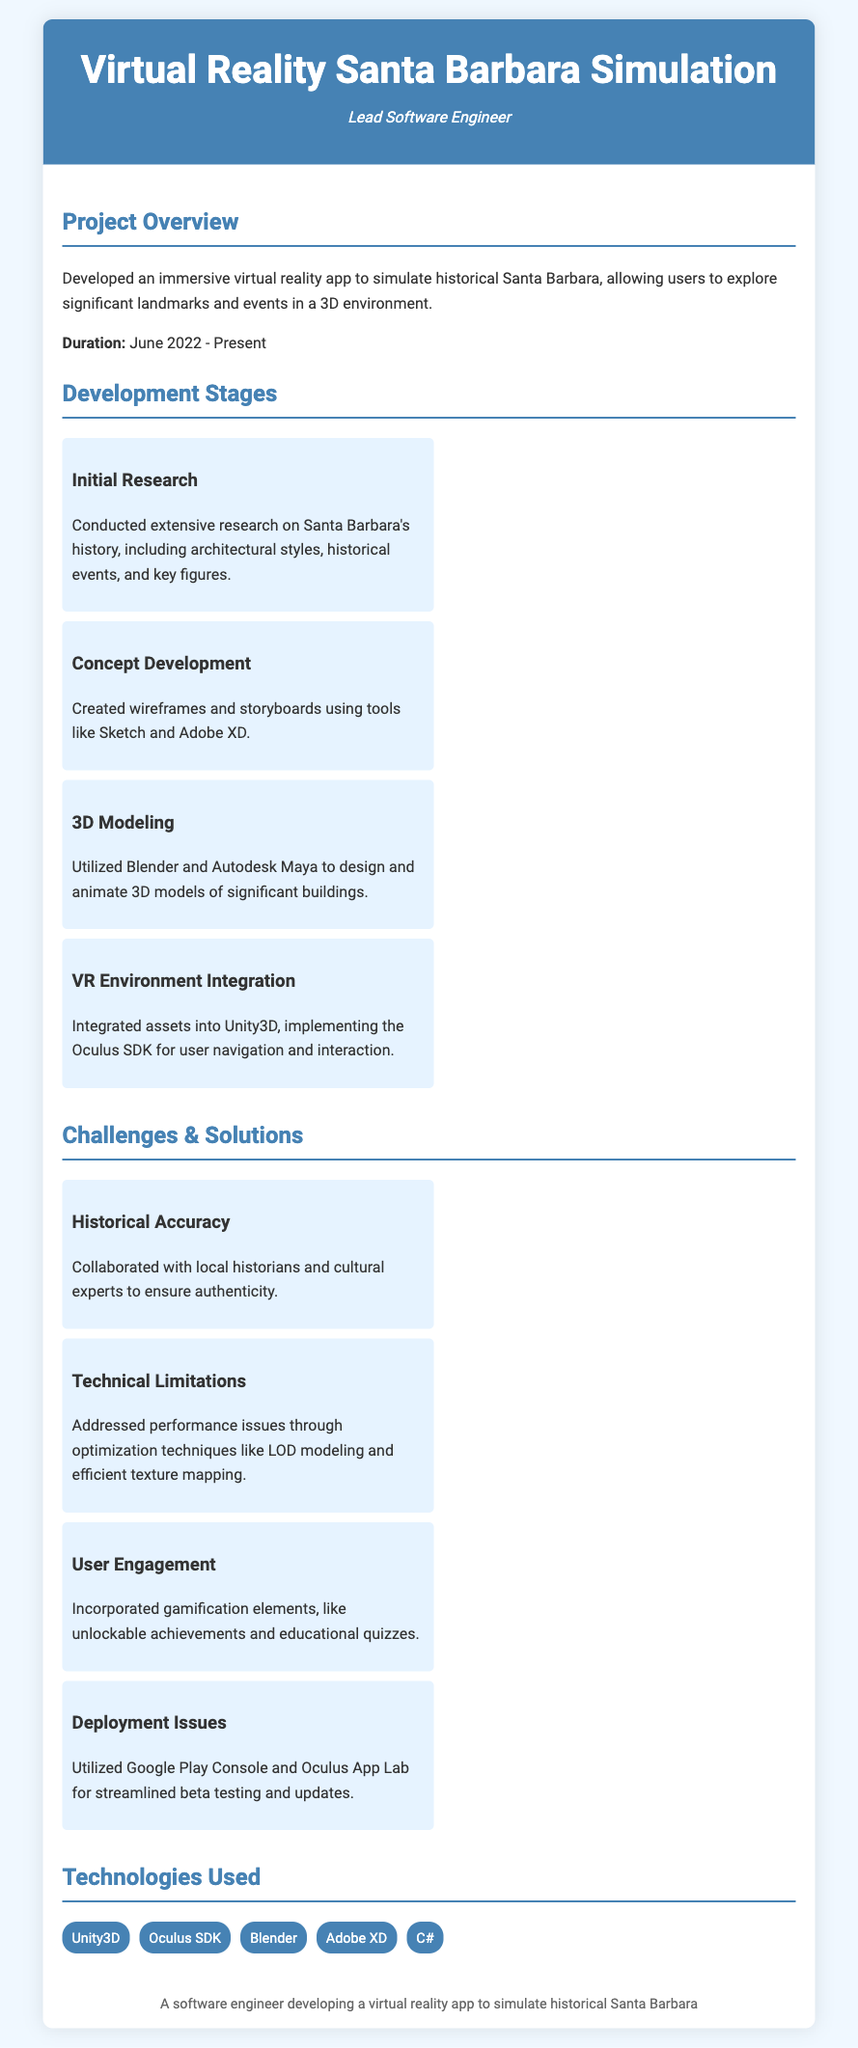What is the name of the project? The project is named "Virtual Reality Santa Barbara Simulation" as mentioned in the header.
Answer: Virtual Reality Santa Barbara Simulation Who was the lead software engineer? The role is specified as "Lead Software Engineer" in the header.
Answer: Lead Software Engineer What was conducted during the initial research stage? The initial research stage involved conducting extensive research on Santa Barbara's history.
Answer: Extensive research on Santa Barbara's history Which software was used for 3D modeling? The document states that Blender and Autodesk Maya were utilized for 3D modeling.
Answer: Blender and Autodesk Maya What technique was used to address performance issues? The document mentions optimization techniques like LOD modeling for addressing performance issues.
Answer: LOD modeling What is one of the gamification elements incorporated in the app? The document specifies that unlockable achievements were one of the gamification elements used.
Answer: Unlockable achievements What dates outline the project duration? The project duration is listed as "June 2022 - Present" in the project overview.
Answer: June 2022 - Present How many challenges are listed in the document? The document outlines four challenges faced during the project.
Answer: Four challenges What technology is used for environment integration? The document indicates that Unity3D was used for the VR environment integration.
Answer: Unity3D What platforms were used for deployment? The document mentions Google Play Console and Oculus App Lab for deployment.
Answer: Google Play Console and Oculus App Lab 